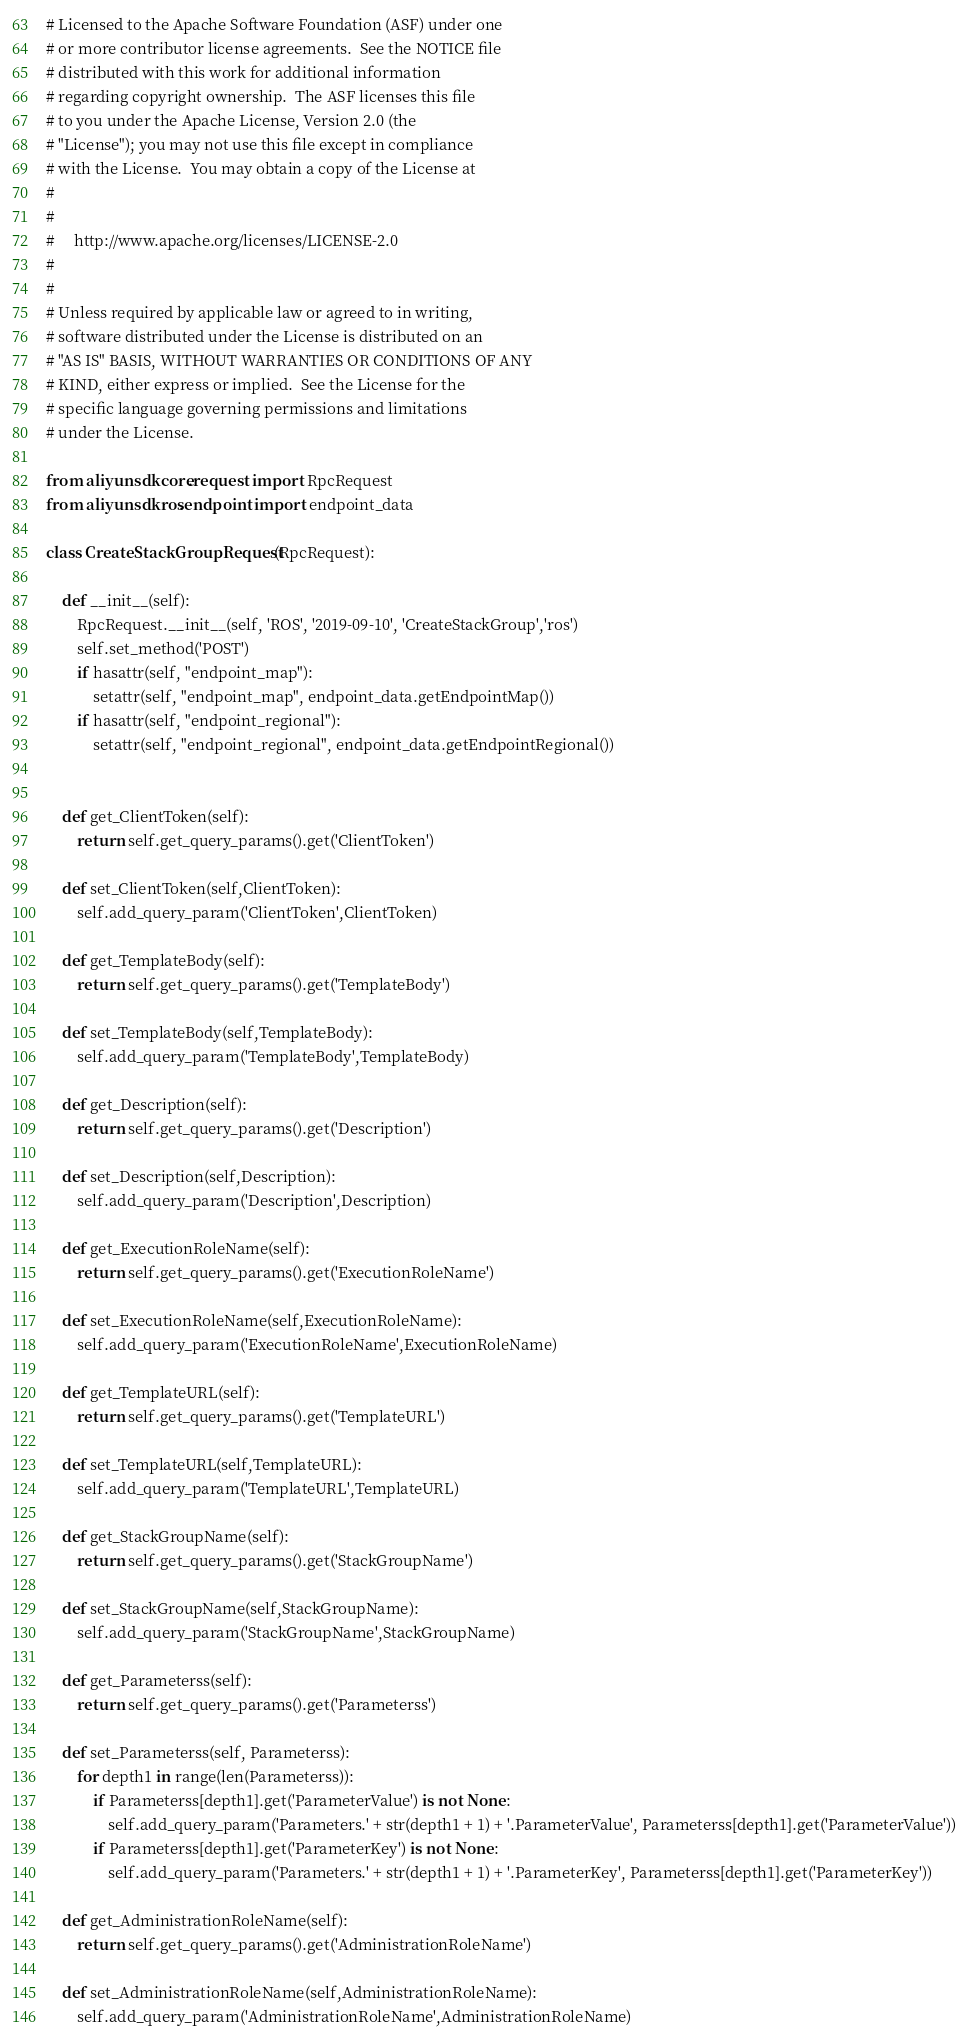<code> <loc_0><loc_0><loc_500><loc_500><_Python_># Licensed to the Apache Software Foundation (ASF) under one
# or more contributor license agreements.  See the NOTICE file
# distributed with this work for additional information
# regarding copyright ownership.  The ASF licenses this file
# to you under the Apache License, Version 2.0 (the
# "License"); you may not use this file except in compliance
# with the License.  You may obtain a copy of the License at
#
#
#     http://www.apache.org/licenses/LICENSE-2.0
#
#
# Unless required by applicable law or agreed to in writing,
# software distributed under the License is distributed on an
# "AS IS" BASIS, WITHOUT WARRANTIES OR CONDITIONS OF ANY
# KIND, either express or implied.  See the License for the
# specific language governing permissions and limitations
# under the License.

from aliyunsdkcore.request import RpcRequest
from aliyunsdkros.endpoint import endpoint_data

class CreateStackGroupRequest(RpcRequest):

	def __init__(self):
		RpcRequest.__init__(self, 'ROS', '2019-09-10', 'CreateStackGroup','ros')
		self.set_method('POST')
		if hasattr(self, "endpoint_map"):
			setattr(self, "endpoint_map", endpoint_data.getEndpointMap())
		if hasattr(self, "endpoint_regional"):
			setattr(self, "endpoint_regional", endpoint_data.getEndpointRegional())


	def get_ClientToken(self):
		return self.get_query_params().get('ClientToken')

	def set_ClientToken(self,ClientToken):
		self.add_query_param('ClientToken',ClientToken)

	def get_TemplateBody(self):
		return self.get_query_params().get('TemplateBody')

	def set_TemplateBody(self,TemplateBody):
		self.add_query_param('TemplateBody',TemplateBody)

	def get_Description(self):
		return self.get_query_params().get('Description')

	def set_Description(self,Description):
		self.add_query_param('Description',Description)

	def get_ExecutionRoleName(self):
		return self.get_query_params().get('ExecutionRoleName')

	def set_ExecutionRoleName(self,ExecutionRoleName):
		self.add_query_param('ExecutionRoleName',ExecutionRoleName)

	def get_TemplateURL(self):
		return self.get_query_params().get('TemplateURL')

	def set_TemplateURL(self,TemplateURL):
		self.add_query_param('TemplateURL',TemplateURL)

	def get_StackGroupName(self):
		return self.get_query_params().get('StackGroupName')

	def set_StackGroupName(self,StackGroupName):
		self.add_query_param('StackGroupName',StackGroupName)

	def get_Parameterss(self):
		return self.get_query_params().get('Parameterss')

	def set_Parameterss(self, Parameterss):
		for depth1 in range(len(Parameterss)):
			if Parameterss[depth1].get('ParameterValue') is not None:
				self.add_query_param('Parameters.' + str(depth1 + 1) + '.ParameterValue', Parameterss[depth1].get('ParameterValue'))
			if Parameterss[depth1].get('ParameterKey') is not None:
				self.add_query_param('Parameters.' + str(depth1 + 1) + '.ParameterKey', Parameterss[depth1].get('ParameterKey'))

	def get_AdministrationRoleName(self):
		return self.get_query_params().get('AdministrationRoleName')

	def set_AdministrationRoleName(self,AdministrationRoleName):
		self.add_query_param('AdministrationRoleName',AdministrationRoleName)</code> 